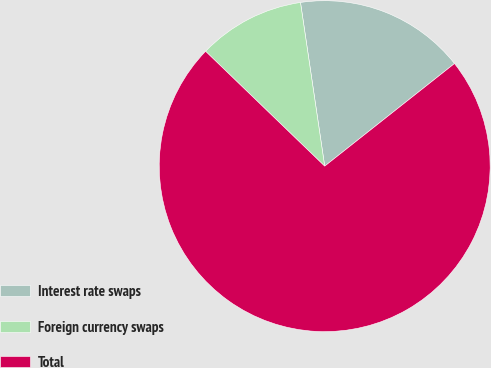<chart> <loc_0><loc_0><loc_500><loc_500><pie_chart><fcel>Interest rate swaps<fcel>Foreign currency swaps<fcel>Total<nl><fcel>16.69%<fcel>10.45%<fcel>72.85%<nl></chart> 